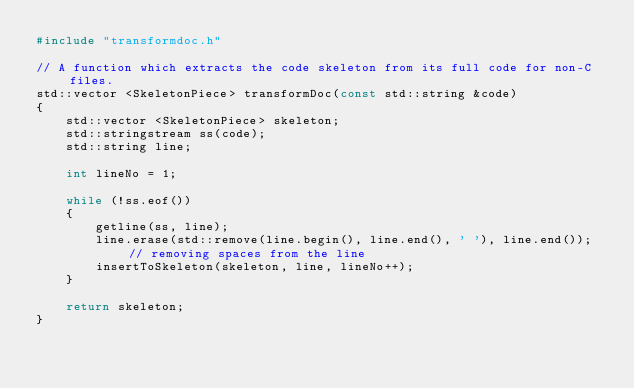<code> <loc_0><loc_0><loc_500><loc_500><_C++_>#include "transformdoc.h"

// A function which extracts the code skeleton from its full code for non-C files.
std::vector <SkeletonPiece> transformDoc(const std::string &code)
{
    std::vector <SkeletonPiece> skeleton;
    std::stringstream ss(code);
    std::string line;

    int lineNo = 1;

    while (!ss.eof())
    {
        getline(ss, line);
        line.erase(std::remove(line.begin(), line.end(), ' '), line.end()); // removing spaces from the line
        insertToSkeleton(skeleton, line, lineNo++);
    }

    return skeleton;
}
</code> 